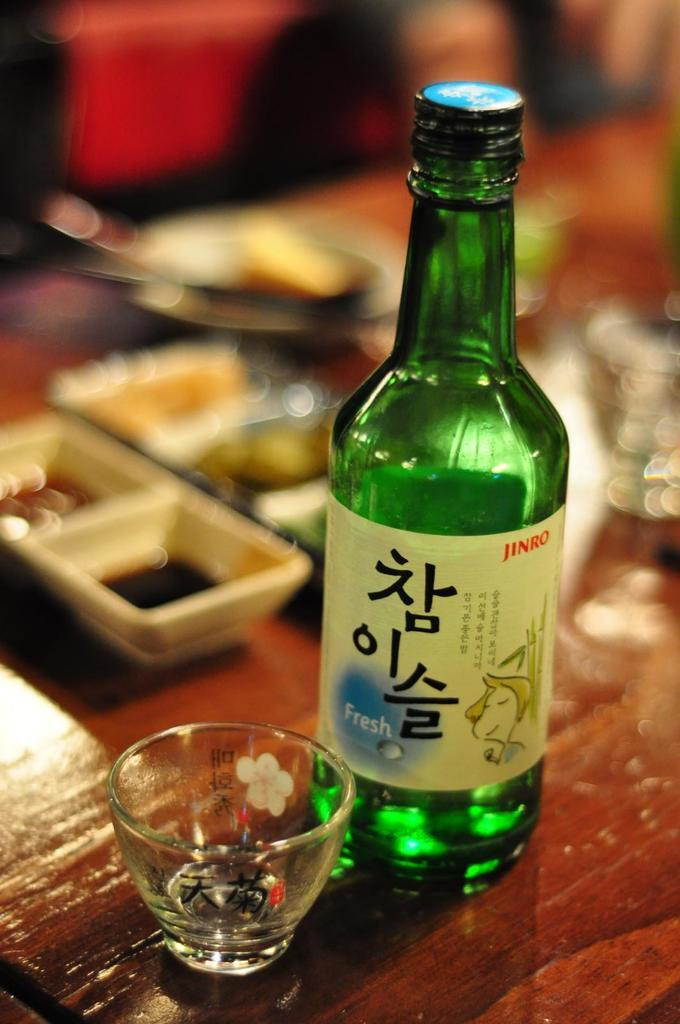What is in the image that is related to a beverage? There is a beer bottle with a label in the image. What type of container is on the table in the image? There is a glass bowl on a table in the image. What can be seen in the background of the image? There are square-shaped plates in the background of the image. What is present on the table that suggests a meal or snack? There is food on the table in the image. How many brass instruments are present in the image? There is no brass instrument present in the image. What is the amount of food on the table in the image? The amount of food on the table cannot be determined from the image alone. 